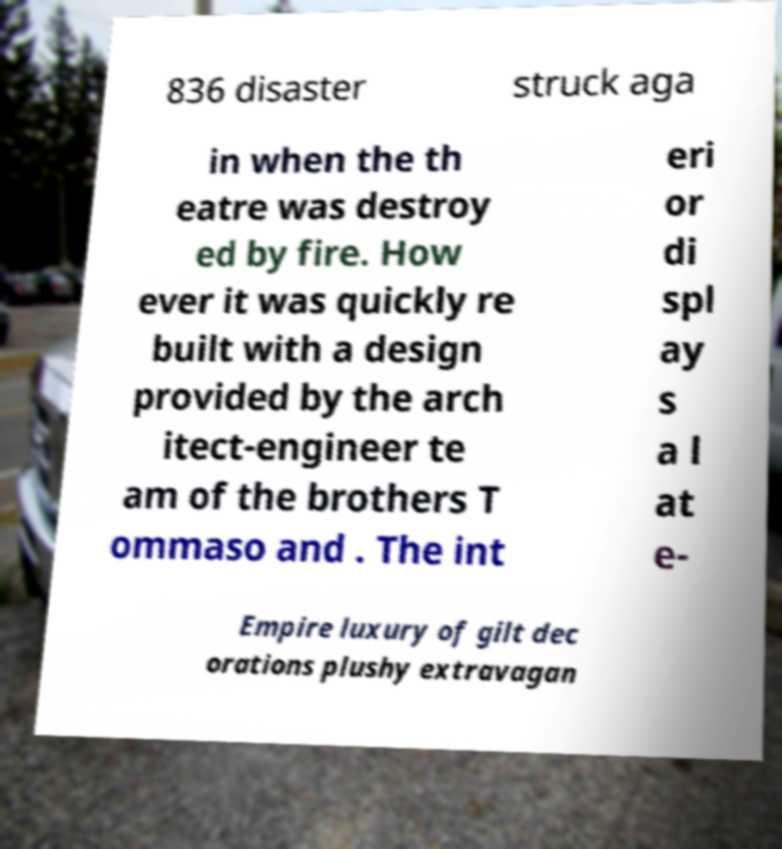For documentation purposes, I need the text within this image transcribed. Could you provide that? 836 disaster struck aga in when the th eatre was destroy ed by fire. How ever it was quickly re built with a design provided by the arch itect-engineer te am of the brothers T ommaso and . The int eri or di spl ay s a l at e- Empire luxury of gilt dec orations plushy extravagan 